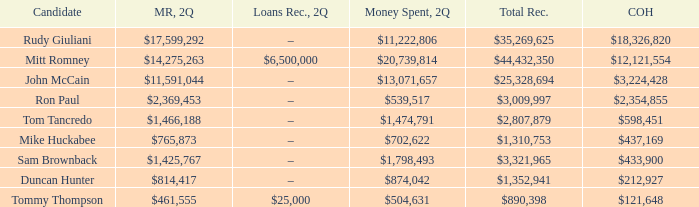Name the money spent for 2Q having candidate of john mccain $13,071,657. 